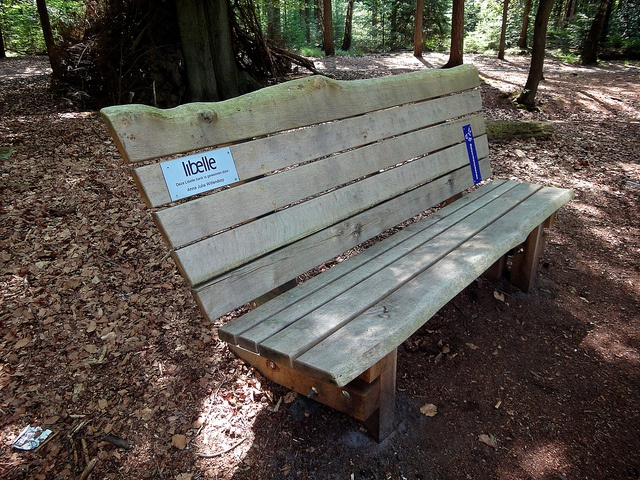Describe the objects in this image and their specific colors. I can see a bench in darkgreen, darkgray, gray, and black tones in this image. 